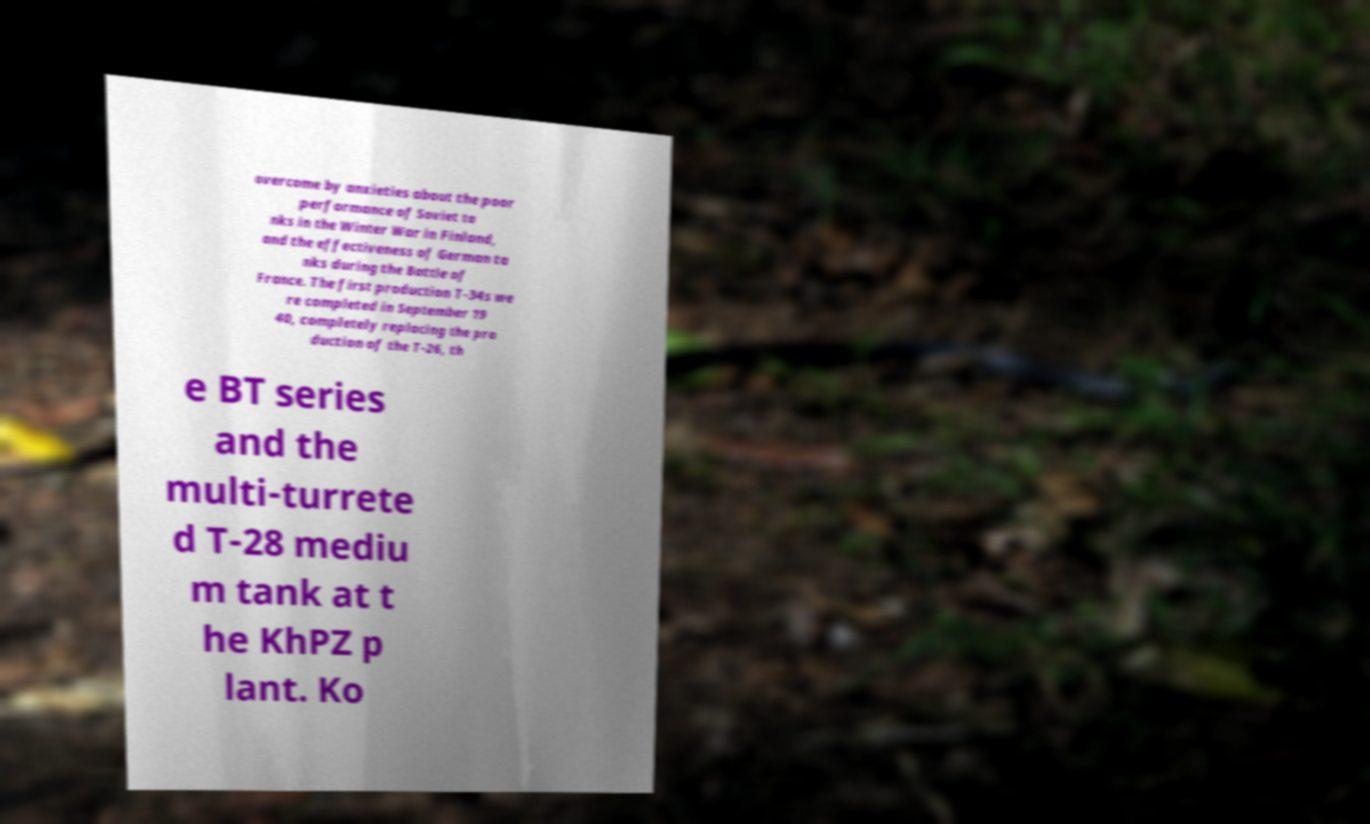I need the written content from this picture converted into text. Can you do that? overcome by anxieties about the poor performance of Soviet ta nks in the Winter War in Finland, and the effectiveness of German ta nks during the Battle of France. The first production T-34s we re completed in September 19 40, completely replacing the pro duction of the T-26, th e BT series and the multi-turrete d T-28 mediu m tank at t he KhPZ p lant. Ko 